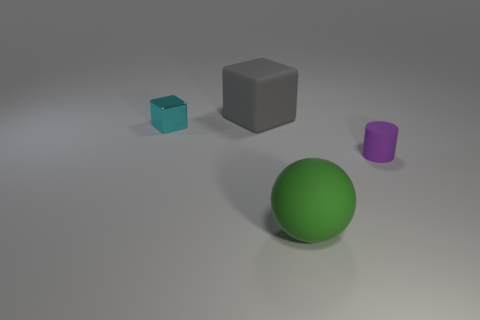Are the purple cylinder and the large thing on the left side of the green object made of the same material?
Give a very brief answer. Yes. Is the number of gray rubber cubes less than the number of red rubber cubes?
Your answer should be very brief. No. There is a large green thing that is the same material as the small purple thing; what shape is it?
Provide a succinct answer. Sphere. There is a large object behind the tiny object that is in front of the tiny metallic object; how many large blocks are behind it?
Your response must be concise. 0. The object that is to the right of the cyan thing and behind the purple matte thing has what shape?
Provide a short and direct response. Cube. Is the number of small purple matte things that are on the right side of the small purple rubber cylinder less than the number of small gray rubber cubes?
Your answer should be compact. No. What number of small objects are purple rubber cylinders or rubber balls?
Keep it short and to the point. 1. The cyan shiny thing is what size?
Make the answer very short. Small. Is there any other thing that has the same material as the big gray thing?
Your answer should be very brief. Yes. How many shiny blocks are in front of the big rubber cube?
Your response must be concise. 1. 